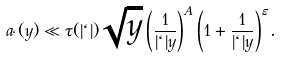Convert formula to latex. <formula><loc_0><loc_0><loc_500><loc_500>a _ { \ell } ( y ) \ll \tau ( | \ell | ) \sqrt { y } \left ( \frac { 1 } { | \ell | y } \right ) ^ { A } \left ( 1 + \frac { 1 } { | \ell | y } \right ) ^ { \varepsilon } .</formula> 